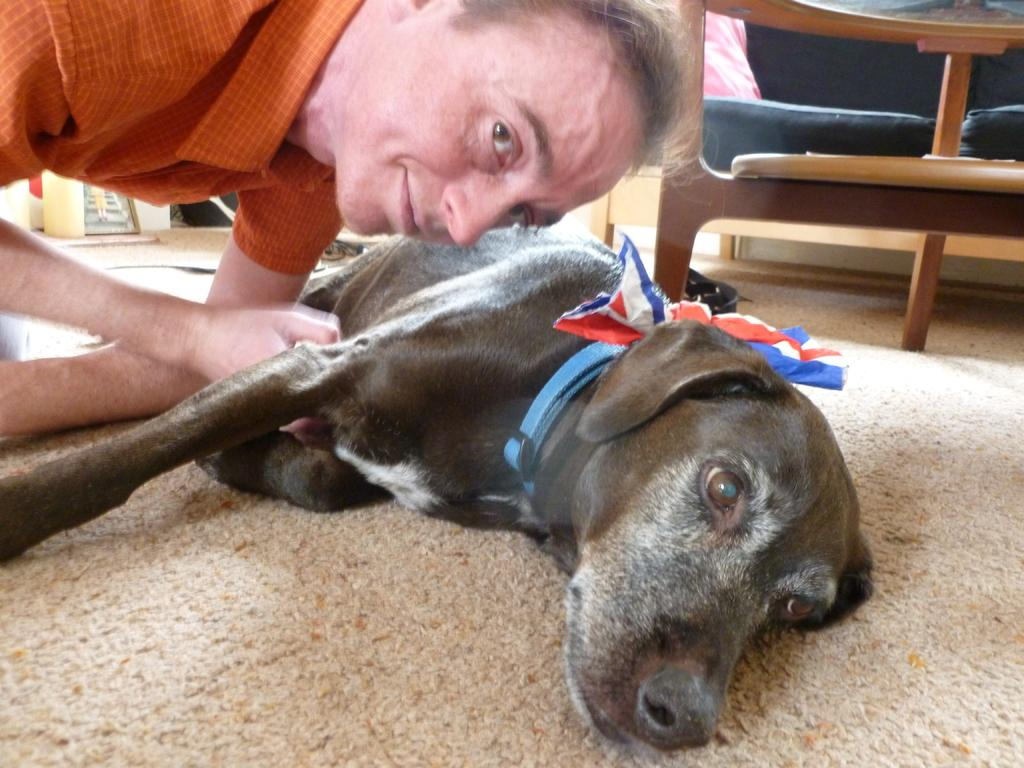Who is present in the image? There is a man in the image. What is the man holding? The man is holding a dog. What piece of furniture is visible in the image? There is a sofa in the image. What type of record is the man listening to on the sofa? There is no record present in the image; the man is holding a dog. What kind of muscle is the man exercising while holding the dog? The image does not show the man exercising any muscles; he is simply holding a dog. 